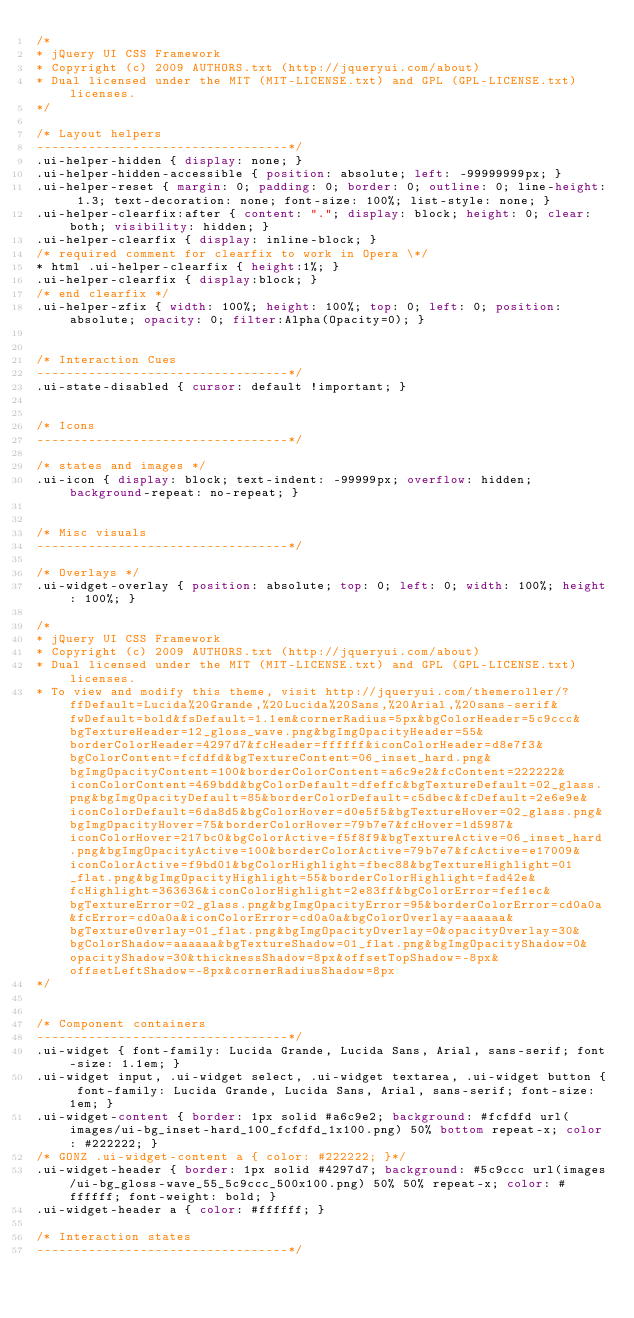<code> <loc_0><loc_0><loc_500><loc_500><_CSS_>/*
* jQuery UI CSS Framework
* Copyright (c) 2009 AUTHORS.txt (http://jqueryui.com/about)
* Dual licensed under the MIT (MIT-LICENSE.txt) and GPL (GPL-LICENSE.txt) licenses.
*/

/* Layout helpers
----------------------------------*/
.ui-helper-hidden { display: none; }
.ui-helper-hidden-accessible { position: absolute; left: -99999999px; }
.ui-helper-reset { margin: 0; padding: 0; border: 0; outline: 0; line-height: 1.3; text-decoration: none; font-size: 100%; list-style: none; }
.ui-helper-clearfix:after { content: "."; display: block; height: 0; clear: both; visibility: hidden; }
.ui-helper-clearfix { display: inline-block; }
/* required comment for clearfix to work in Opera \*/
* html .ui-helper-clearfix { height:1%; }
.ui-helper-clearfix { display:block; }
/* end clearfix */
.ui-helper-zfix { width: 100%; height: 100%; top: 0; left: 0; position: absolute; opacity: 0; filter:Alpha(Opacity=0); }


/* Interaction Cues
----------------------------------*/
.ui-state-disabled { cursor: default !important; }


/* Icons
----------------------------------*/

/* states and images */
.ui-icon { display: block; text-indent: -99999px; overflow: hidden; background-repeat: no-repeat; }


/* Misc visuals
----------------------------------*/

/* Overlays */
.ui-widget-overlay { position: absolute; top: 0; left: 0; width: 100%; height: 100%; }

/*
* jQuery UI CSS Framework
* Copyright (c) 2009 AUTHORS.txt (http://jqueryui.com/about)
* Dual licensed under the MIT (MIT-LICENSE.txt) and GPL (GPL-LICENSE.txt) licenses.
* To view and modify this theme, visit http://jqueryui.com/themeroller/?ffDefault=Lucida%20Grande,%20Lucida%20Sans,%20Arial,%20sans-serif&fwDefault=bold&fsDefault=1.1em&cornerRadius=5px&bgColorHeader=5c9ccc&bgTextureHeader=12_gloss_wave.png&bgImgOpacityHeader=55&borderColorHeader=4297d7&fcHeader=ffffff&iconColorHeader=d8e7f3&bgColorContent=fcfdfd&bgTextureContent=06_inset_hard.png&bgImgOpacityContent=100&borderColorContent=a6c9e2&fcContent=222222&iconColorContent=469bdd&bgColorDefault=dfeffc&bgTextureDefault=02_glass.png&bgImgOpacityDefault=85&borderColorDefault=c5dbec&fcDefault=2e6e9e&iconColorDefault=6da8d5&bgColorHover=d0e5f5&bgTextureHover=02_glass.png&bgImgOpacityHover=75&borderColorHover=79b7e7&fcHover=1d5987&iconColorHover=217bc0&bgColorActive=f5f8f9&bgTextureActive=06_inset_hard.png&bgImgOpacityActive=100&borderColorActive=79b7e7&fcActive=e17009&iconColorActive=f9bd01&bgColorHighlight=fbec88&bgTextureHighlight=01_flat.png&bgImgOpacityHighlight=55&borderColorHighlight=fad42e&fcHighlight=363636&iconColorHighlight=2e83ff&bgColorError=fef1ec&bgTextureError=02_glass.png&bgImgOpacityError=95&borderColorError=cd0a0a&fcError=cd0a0a&iconColorError=cd0a0a&bgColorOverlay=aaaaaa&bgTextureOverlay=01_flat.png&bgImgOpacityOverlay=0&opacityOverlay=30&bgColorShadow=aaaaaa&bgTextureShadow=01_flat.png&bgImgOpacityShadow=0&opacityShadow=30&thicknessShadow=8px&offsetTopShadow=-8px&offsetLeftShadow=-8px&cornerRadiusShadow=8px
*/


/* Component containers
----------------------------------*/
.ui-widget { font-family: Lucida Grande, Lucida Sans, Arial, sans-serif; font-size: 1.1em; }
.ui-widget input, .ui-widget select, .ui-widget textarea, .ui-widget button { font-family: Lucida Grande, Lucida Sans, Arial, sans-serif; font-size: 1em; }
.ui-widget-content { border: 1px solid #a6c9e2; background: #fcfdfd url(images/ui-bg_inset-hard_100_fcfdfd_1x100.png) 50% bottom repeat-x; color: #222222; }
/* GONZ .ui-widget-content a { color: #222222; }*/
.ui-widget-header { border: 1px solid #4297d7; background: #5c9ccc url(images/ui-bg_gloss-wave_55_5c9ccc_500x100.png) 50% 50% repeat-x; color: #ffffff; font-weight: bold; }
.ui-widget-header a { color: #ffffff; }

/* Interaction states
----------------------------------*/</code> 